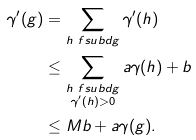<formula> <loc_0><loc_0><loc_500><loc_500>\gamma ^ { \prime } ( g ) & = \sum _ { h \ f s u b d g } \gamma ^ { \prime } ( h ) \\ & \leq \sum _ { \substack { h \ f s u b d g \\ \gamma ^ { \prime } ( h ) > 0 } } a \gamma ( h ) + b \\ & \leq M b + a \gamma ( g ) .</formula> 